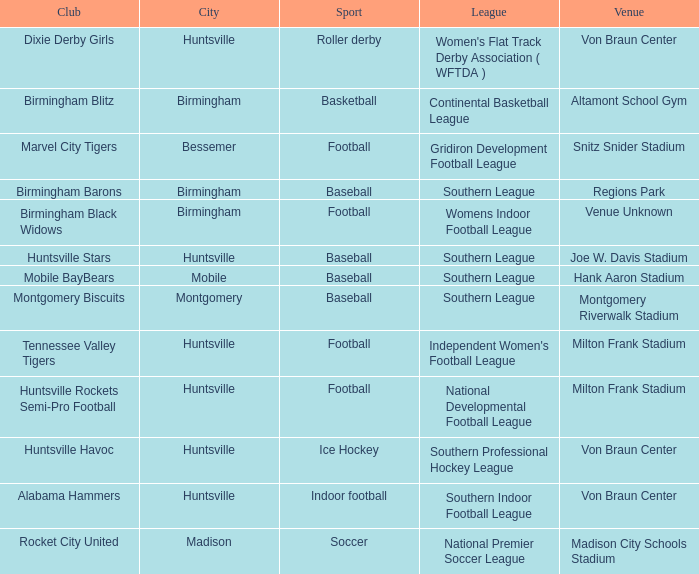In which place did a basketball team play? Altamont School Gym. 